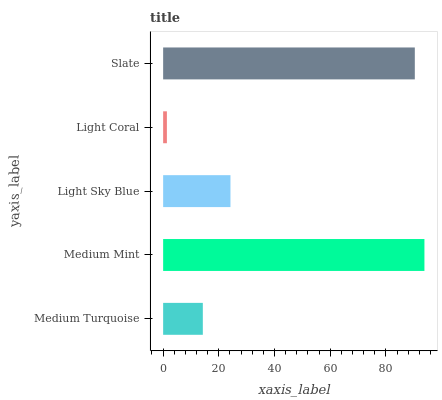Is Light Coral the minimum?
Answer yes or no. Yes. Is Medium Mint the maximum?
Answer yes or no. Yes. Is Light Sky Blue the minimum?
Answer yes or no. No. Is Light Sky Blue the maximum?
Answer yes or no. No. Is Medium Mint greater than Light Sky Blue?
Answer yes or no. Yes. Is Light Sky Blue less than Medium Mint?
Answer yes or no. Yes. Is Light Sky Blue greater than Medium Mint?
Answer yes or no. No. Is Medium Mint less than Light Sky Blue?
Answer yes or no. No. Is Light Sky Blue the high median?
Answer yes or no. Yes. Is Light Sky Blue the low median?
Answer yes or no. Yes. Is Slate the high median?
Answer yes or no. No. Is Medium Mint the low median?
Answer yes or no. No. 